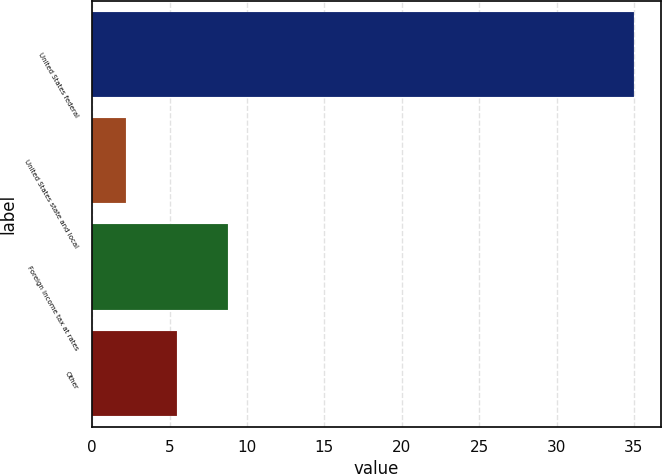<chart> <loc_0><loc_0><loc_500><loc_500><bar_chart><fcel>United States federal<fcel>United States state and local<fcel>Foreign income tax at rates<fcel>Other<nl><fcel>35<fcel>2.2<fcel>8.76<fcel>5.48<nl></chart> 